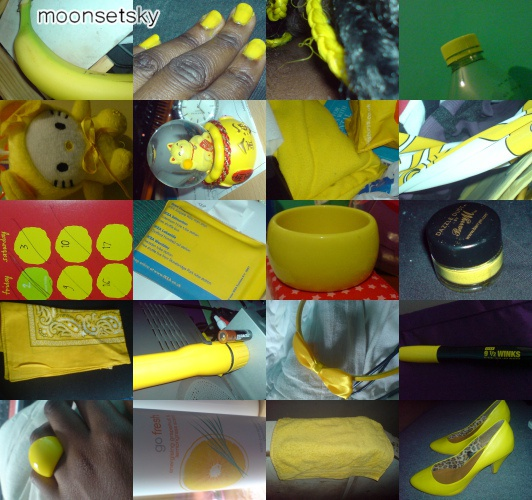Describe the objects in this image and their specific colors. I can see people in darkgreen, gray, and darkgray tones, bowl in darkgreen, olive, and maroon tones, people in darkgreen, black, gray, and olive tones, bottle in darkgreen, black, khaki, and gray tones, and banana in darkgreen, khaki, and olive tones in this image. 